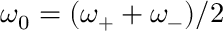<formula> <loc_0><loc_0><loc_500><loc_500>\omega _ { 0 } = ( \omega _ { + } + \omega _ { - } ) / 2</formula> 